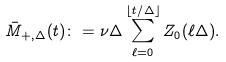Convert formula to latex. <formula><loc_0><loc_0><loc_500><loc_500>\bar { M } _ { + , \Delta } ( t ) \colon = \nu \Delta \sum _ { \ell = 0 } ^ { \lfloor t / \Delta \rfloor } Z _ { 0 } ( \ell \Delta ) .</formula> 